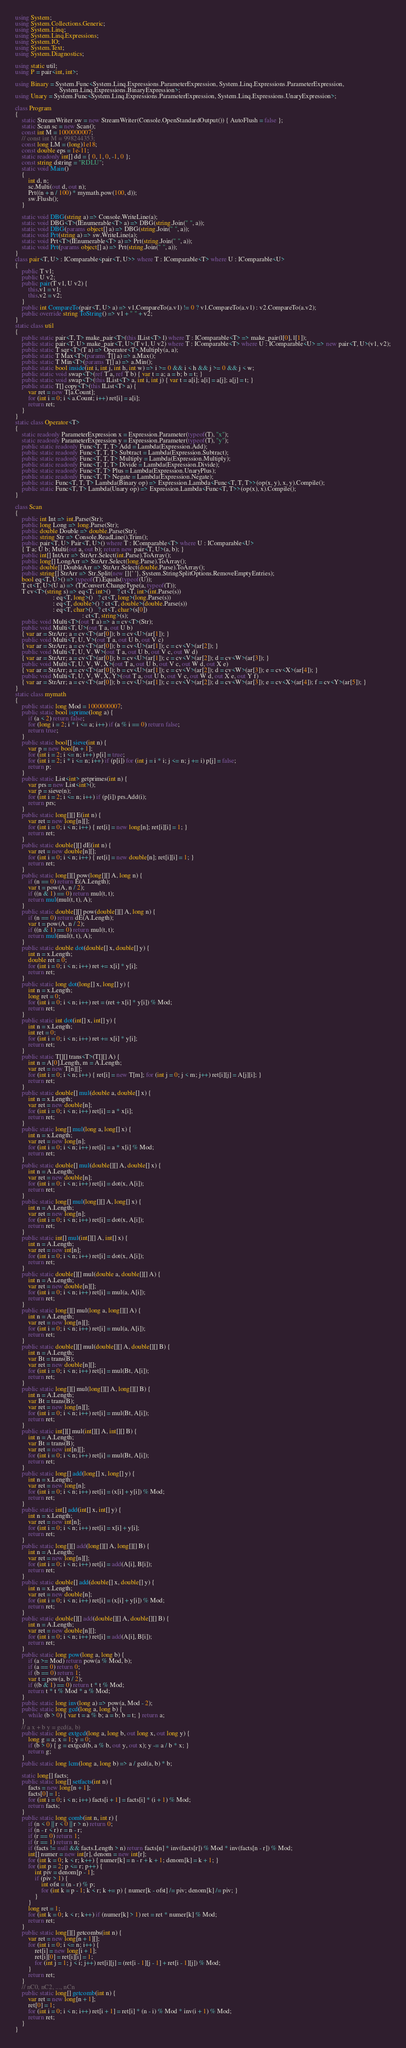Convert code to text. <code><loc_0><loc_0><loc_500><loc_500><_C#_>using System;
using System.Collections.Generic;
using System.Linq;
using System.Linq.Expressions;
using System.IO;
using System.Text;
using System.Diagnostics;

using static util;
using P = pair<int, int>;

using Binary = System.Func<System.Linq.Expressions.ParameterExpression, System.Linq.Expressions.ParameterExpression,
                           System.Linq.Expressions.BinaryExpression>;
using Unary = System.Func<System.Linq.Expressions.ParameterExpression, System.Linq.Expressions.UnaryExpression>;

class Program
{
    static StreamWriter sw = new StreamWriter(Console.OpenStandardOutput()) { AutoFlush = false };
    static Scan sc = new Scan();
    const int M = 1000000007;
    // const int M = 998244353;
    const long LM = (long)1e18;
    const double eps = 1e-11;
    static readonly int[] dd = { 0, 1, 0, -1, 0 };
    const string dstring = "RDLU";
    static void Main()
    {
        int d, n;
        sc.Multi(out d, out n);
        Prt((n + n / 100) * mymath.pow(100, d));
        sw.Flush();
    }

    static void DBG(string a) => Console.WriteLine(a);
    static void DBG<T>(IEnumerable<T> a) => DBG(string.Join(" ", a));
    static void DBG(params object[] a) => DBG(string.Join(" ", a));
    static void Prt(string a) => sw.WriteLine(a);
    static void Prt<T>(IEnumerable<T> a) => Prt(string.Join(" ", a));
    static void Prt(params object[] a) => Prt(string.Join(" ", a));
}
class pair<T, U> : IComparable<pair<T, U>> where T : IComparable<T> where U : IComparable<U>
{
    public T v1;
    public U v2;
    public pair(T v1, U v2) {
        this.v1 = v1;
        this.v2 = v2;
    }
    public int CompareTo(pair<T, U> a) => v1.CompareTo(a.v1) != 0 ? v1.CompareTo(a.v1) : v2.CompareTo(a.v2);
    public override string ToString() => v1 + " " + v2;
}
static class util
{
    public static pair<T, T> make_pair<T>(this IList<T> l) where T : IComparable<T> => make_pair(l[0], l[1]);
    public static pair<T, U> make_pair<T, U>(T v1, U v2) where T : IComparable<T> where U : IComparable<U> => new pair<T, U>(v1, v2);
    public static T sqr<T>(T a) => Operator<T>.Multiply(a, a);
    public static T Max<T>(params T[] a) => a.Max();
    public static T Min<T>(params T[] a) => a.Min();
    public static bool inside(int i, int j, int h, int w) => i >= 0 && i < h && j >= 0 && j < w;
    public static void swap<T>(ref T a, ref T b) { var t = a; a = b; b = t; }
    public static void swap<T>(this IList<T> a, int i, int j) { var t = a[i]; a[i] = a[j]; a[j] = t; }
    public static T[] copy<T>(this IList<T> a) {
        var ret = new T[a.Count];
        for (int i = 0; i < a.Count; i++) ret[i] = a[i];
        return ret;
    }
}
static class Operator<T>
{
    static readonly ParameterExpression x = Expression.Parameter(typeof(T), "x");
    static readonly ParameterExpression y = Expression.Parameter(typeof(T), "y");
    public static readonly Func<T, T, T> Add = Lambda(Expression.Add);
    public static readonly Func<T, T, T> Subtract = Lambda(Expression.Subtract);
    public static readonly Func<T, T, T> Multiply = Lambda(Expression.Multiply);
    public static readonly Func<T, T, T> Divide = Lambda(Expression.Divide);
    public static readonly Func<T, T> Plus = Lambda(Expression.UnaryPlus);
    public static readonly Func<T, T> Negate = Lambda(Expression.Negate);
    public static Func<T, T, T> Lambda(Binary op) => Expression.Lambda<Func<T, T, T>>(op(x, y), x, y).Compile();
    public static Func<T, T> Lambda(Unary op) => Expression.Lambda<Func<T, T>>(op(x), x).Compile();
}

class Scan
{
    public int Int => int.Parse(Str);
    public long Long => long.Parse(Str);
    public double Double => double.Parse(Str);
    public string Str => Console.ReadLine().Trim();
    public pair<T, U> Pair<T, U>() where T : IComparable<T> where U : IComparable<U>
    { T a; U b; Multi(out a, out b); return new pair<T, U>(a, b); }
    public int[] IntArr => StrArr.Select(int.Parse).ToArray();
    public long[] LongArr => StrArr.Select(long.Parse).ToArray();
    public double[] DoubleArr => StrArr.Select(double.Parse).ToArray();
    public string[] StrArr => Str.Split(new []{' '}, System.StringSplitOptions.RemoveEmptyEntries);
    bool eq<T, U>() => typeof(T).Equals(typeof(U));
    T ct<T, U>(U a) => (T)Convert.ChangeType(a, typeof(T));
    T cv<T>(string s) => eq<T, int>()    ? ct<T, int>(int.Parse(s))
                       : eq<T, long>()   ? ct<T, long>(long.Parse(s))
                       : eq<T, double>() ? ct<T, double>(double.Parse(s))
                       : eq<T, char>()   ? ct<T, char>(s[0])
                                         : ct<T, string>(s);
    public void Multi<T>(out T a) => a = cv<T>(Str);
    public void Multi<T, U>(out T a, out U b)
    { var ar = StrArr; a = cv<T>(ar[0]); b = cv<U>(ar[1]); }
    public void Multi<T, U, V>(out T a, out U b, out V c)
    { var ar = StrArr; a = cv<T>(ar[0]); b = cv<U>(ar[1]); c = cv<V>(ar[2]); }
    public void Multi<T, U, V, W>(out T a, out U b, out V c, out W d)
    { var ar = StrArr; a = cv<T>(ar[0]); b = cv<U>(ar[1]); c = cv<V>(ar[2]); d = cv<W>(ar[3]); }
    public void Multi<T, U, V, W, X>(out T a, out U b, out V c, out W d, out X e)
    { var ar = StrArr; a = cv<T>(ar[0]); b = cv<U>(ar[1]); c = cv<V>(ar[2]); d = cv<W>(ar[3]); e = cv<X>(ar[4]); }
    public void Multi<T, U, V, W, X, Y>(out T a, out U b, out V c, out W d, out X e, out Y f)
    { var ar = StrArr; a = cv<T>(ar[0]); b = cv<U>(ar[1]); c = cv<V>(ar[2]); d = cv<W>(ar[3]); e = cv<X>(ar[4]); f = cv<Y>(ar[5]); }
}
static class mymath
{
    public static long Mod = 1000000007;
    public static bool isprime(long a) {
        if (a < 2) return false;
        for (long i = 2; i * i <= a; i++) if (a % i == 0) return false;
        return true;
    }
    public static bool[] sieve(int n) {
        var p = new bool[n + 1];
        for (int i = 2; i <= n; i++) p[i] = true;
        for (int i = 2; i * i <= n; i++) if (p[i]) for (int j = i * i; j <= n; j += i) p[j] = false;
        return p;
    }
    public static List<int> getprimes(int n) {
        var prs = new List<int>();
        var p = sieve(n);
        for (int i = 2; i <= n; i++) if (p[i]) prs.Add(i);
        return prs;
    }
    public static long[][] E(int n) {
        var ret = new long[n][];
        for (int i = 0; i < n; i++) { ret[i] = new long[n]; ret[i][i] = 1; }
        return ret;
    }
    public static double[][] dE(int n) {
        var ret = new double[n][];
        for (int i = 0; i < n; i++) { ret[i] = new double[n]; ret[i][i] = 1; }
        return ret;
    }
    public static long[][] pow(long[][] A, long n) {
        if (n == 0) return E(A.Length);
        var t = pow(A, n / 2);
        if ((n & 1) == 0) return mul(t, t);
        return mul(mul(t, t), A);
    }
    public static double[][] pow(double[][] A, long n) {
        if (n == 0) return dE(A.Length);
        var t = pow(A, n / 2);
        if ((n & 1) == 0) return mul(t, t);
        return mul(mul(t, t), A);
    }
    public static double dot(double[] x, double[] y) {
        int n = x.Length;
        double ret = 0;
        for (int i = 0; i < n; i++) ret += x[i] * y[i];
        return ret;
    }
    public static long dot(long[] x, long[] y) {
        int n = x.Length;
        long ret = 0;
        for (int i = 0; i < n; i++) ret = (ret + x[i] * y[i]) % Mod;
        return ret;
    }
    public static int dot(int[] x, int[] y) {
        int n = x.Length;
        int ret = 0;
        for (int i = 0; i < n; i++) ret += x[i] * y[i];
        return ret;
    }
    public static T[][] trans<T>(T[][] A) {
        int n = A[0].Length, m = A.Length;
        var ret = new T[n][];
        for (int i = 0; i < n; i++) { ret[i] = new T[m]; for (int j = 0; j < m; j++) ret[i][j] = A[j][i]; }
        return ret;
    }
    public static double[] mul(double a, double[] x) {
        int n = x.Length;
        var ret = new double[n];
        for (int i = 0; i < n; i++) ret[i] = a * x[i];
        return ret;
    }
    public static long[] mul(long a, long[] x) {
        int n = x.Length;
        var ret = new long[n];
        for (int i = 0; i < n; i++) ret[i] = a * x[i] % Mod;
        return ret;
    }
    public static double[] mul(double[][] A, double[] x) {
        int n = A.Length;
        var ret = new double[n];
        for (int i = 0; i < n; i++) ret[i] = dot(x, A[i]);
        return ret;
    }
    public static long[] mul(long[][] A, long[] x) {
        int n = A.Length;
        var ret = new long[n];
        for (int i = 0; i < n; i++) ret[i] = dot(x, A[i]);
        return ret;
    }
    public static int[] mul(int[][] A, int[] x) {
        int n = A.Length;
        var ret = new int[n];
        for (int i = 0; i < n; i++) ret[i] = dot(x, A[i]);
        return ret;
    }
    public static double[][] mul(double a, double[][] A) {
        int n = A.Length;
        var ret = new double[n][];
        for (int i = 0; i < n; i++) ret[i] = mul(a, A[i]);
        return ret;
    }
    public static long[][] mul(long a, long[][] A) {
        int n = A.Length;
        var ret = new long[n][];
        for (int i = 0; i < n; i++) ret[i] = mul(a, A[i]);
        return ret;
    }
    public static double[][] mul(double[][] A, double[][] B) {
        int n = A.Length;
        var Bt = trans(B);
        var ret = new double[n][];
        for (int i = 0; i < n; i++) ret[i] = mul(Bt, A[i]);
        return ret;
    }
    public static long[][] mul(long[][] A, long[][] B) {
        int n = A.Length;
        var Bt = trans(B);
        var ret = new long[n][];
        for (int i = 0; i < n; i++) ret[i] = mul(Bt, A[i]);
        return ret;
    }
    public static int[][] mul(int[][] A, int[][] B) {
        int n = A.Length;
        var Bt = trans(B);
        var ret = new int[n][];
        for (int i = 0; i < n; i++) ret[i] = mul(Bt, A[i]);
        return ret;
    }
    public static long[] add(long[] x, long[] y) {
        int n = x.Length;
        var ret = new long[n];
        for (int i = 0; i < n; i++) ret[i] = (x[i] + y[i]) % Mod;
        return ret;
    }
    public static int[] add(int[] x, int[] y) {
        int n = x.Length;
        var ret = new int[n];
        for (int i = 0; i < n; i++) ret[i] = x[i] + y[i];
        return ret;
    }
    public static long[][] add(long[][] A, long[][] B) {
        int n = A.Length;
        var ret = new long[n][];
        for (int i = 0; i < n; i++) ret[i] = add(A[i], B[i]);
        return ret;
    }
    public static double[] add(double[] x, double[] y) {
        int n = x.Length;
        var ret = new double[n];
        for (int i = 0; i < n; i++) ret[i] = (x[i] + y[i]) % Mod;
        return ret;
    }
    public static double[][] add(double[][] A, double[][] B) {
        int n = A.Length;
        var ret = new double[n][];
        for (int i = 0; i < n; i++) ret[i] = add(A[i], B[i]);
        return ret;
    }
    public static long pow(long a, long b) {
        if (a >= Mod) return pow(a % Mod, b);
        if (a == 0) return 0;
        if (b == 0) return 1;
        var t = pow(a, b / 2);
        if ((b & 1) == 0) return t * t % Mod;
        return t * t % Mod * a % Mod;
    }
    public static long inv(long a) => pow(a, Mod - 2);
    public static long gcd(long a, long b) {
        while (b > 0) { var t = a % b; a = b; b = t; } return a;
    }
    // a x + b y = gcd(a, b)
    public static long extgcd(long a, long b, out long x, out long y) {
        long g = a; x = 1; y = 0;
        if (b > 0) { g = extgcd(b, a % b, out y, out x); y -= a / b * x; }
        return g;
    }
    public static long lcm(long a, long b) => a / gcd(a, b) * b;

    static long[] facts;
    public static long[] setfacts(int n) {
        facts = new long[n + 1];
        facts[0] = 1;
        for (int i = 0; i < n; i++) facts[i + 1] = facts[i] * (i + 1) % Mod;
        return facts;
    }
    public static long comb(int n, int r) {
        if (n < 0 || r < 0 || r > n) return 0;
        if (n - r < r) r = n - r;
        if (r == 0) return 1;
        if (r == 1) return n;
        if (facts != null && facts.Length > n) return facts[n] * inv(facts[r]) % Mod * inv(facts[n - r]) % Mod;
        int[] numer = new int[r], denom = new int[r];
        for (int k = 0; k < r; k++) { numer[k] = n - r + k + 1; denom[k] = k + 1; }
        for (int p = 2; p <= r; p++) {
            int piv = denom[p - 1];
            if (piv > 1) {
                int ofst = (n - r) % p;
                for (int k = p - 1; k < r; k += p) { numer[k - ofst] /= piv; denom[k] /= piv; }
            }
        }
        long ret = 1;
        for (int k = 0; k < r; k++) if (numer[k] > 1) ret = ret * numer[k] % Mod;
        return ret;
    }
    public static long[][] getcombs(int n) {
        var ret = new long[n + 1][];
        for (int i = 0; i <= n; i++) {
            ret[i] = new long[i + 1];
            ret[i][0] = ret[i][i] = 1;
            for (int j = 1; j < i; j++) ret[i][j] = (ret[i - 1][j - 1] + ret[i - 1][j]) % Mod;
        }
        return ret;
    }
    // nC0, nC2, ..., nCn
    public static long[] getcomb(int n) {
        var ret = new long[n + 1];
        ret[0] = 1;
        for (int i = 0; i < n; i++) ret[i + 1] = ret[i] * (n - i) % Mod * inv(i + 1) % Mod;
        return ret;
    }
}
</code> 